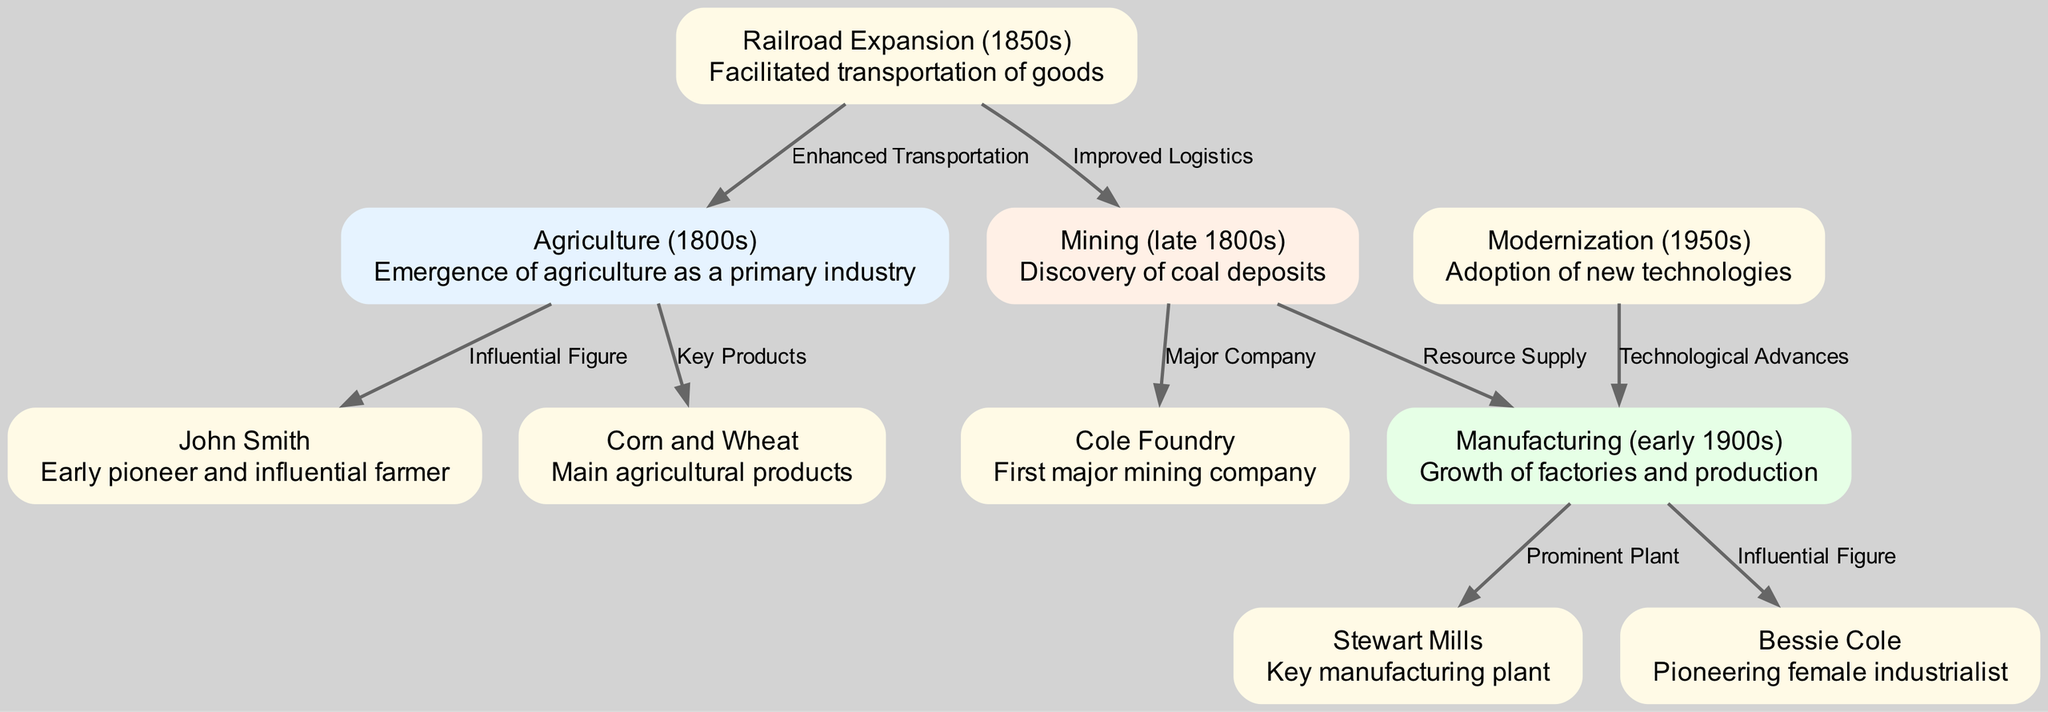What is the first industry highlighted in the flowchart? The flowchart starts with the node labeled "Agriculture (1800s)", indicating that agriculture was the first industry to emerge as a primary industry in Johnson County.
Answer: Agriculture (1800s) Who is identified as an early influential farmer? The node labeled "John Smith" connects to the "Agriculture (1800s)" node, indicating that John Smith is identified as an early pioneer and influential farmer in this industry.
Answer: John Smith What were the main products of agriculture during the 1800s? The "Corn and Wheat" node is linked to "Agriculture (1800s)" and describes the main agricultural products produced in Johnson County during the 1800s.
Answer: Corn and Wheat How did the railroad expansion impact agriculture? The "Railroad Expansion (1850s)" node is connected to the "Agriculture (1800s)" node with the label "Enhanced Transportation," indicating that railroad expansion facilitated transportation of goods, which positively impacted agriculture.
Answer: Enhanced Transportation Which mining company is mentioned as the first major player? The node "Cole Foundry" is directly linked to the "Mining (late 1800s)" node, describing it as the first major mining company discovered during that time after coal deposits were found.
Answer: Cole Foundry What key manufacturing plant is highlighted in the flowchart? The "Stewart Mills" node connects to the "Manufacturing (early 1900s)" node, indicating that Stewart Mills was a prominent manufacturing plant in Johnson County during this period.
Answer: Stewart Mills What role did modernization play in manufacturing in the 1950s? The "Modernization (1950s)" node is connected to the "Manufacturing (early 1900s)" node with the label "Technological Advances," suggesting that modernization brought technological improvements to the manufacturing sector.
Answer: Technological Advances Who is noted as an influential female industrialist? The node "Bessie Cole" is linked to the "Manufacturing (early 1900s)" node, indicating that she is recognized as a pioneering female industrialist during this period.
Answer: Bessie Cole How many edges connect the agriculture node to other nodes? There are three edges directly connecting from the "Agriculture (1800s)" node to other nodes: "John Smith," "Corn and Wheat," and the "Railroad Expansion (1850s)," indicating its strong influence on various aspects.
Answer: 3 